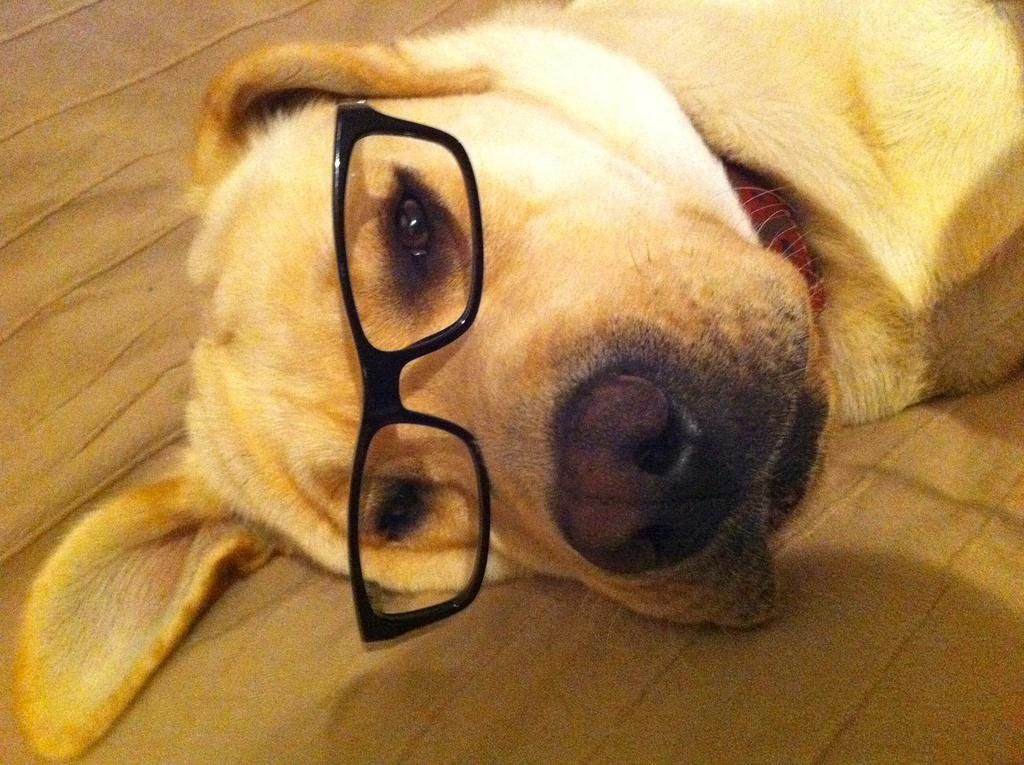What type of animal is in the image? There is a dog in the image. What is the dog doing in the image? The dog is laying on the floor. Is there anything unusual about the dog in the image? Yes, the dog is wearing spectacles. What type of chess piece is the dog playing in the image? There is no chess piece or game of chess present in the image. 